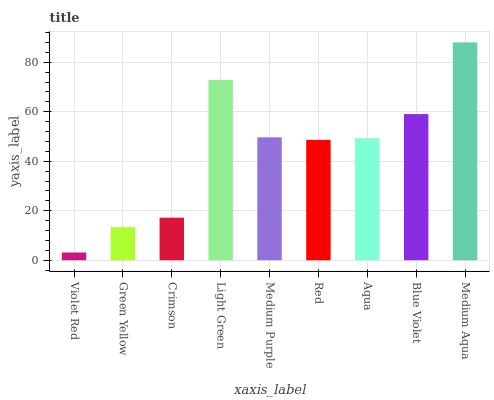Is Violet Red the minimum?
Answer yes or no. Yes. Is Medium Aqua the maximum?
Answer yes or no. Yes. Is Green Yellow the minimum?
Answer yes or no. No. Is Green Yellow the maximum?
Answer yes or no. No. Is Green Yellow greater than Violet Red?
Answer yes or no. Yes. Is Violet Red less than Green Yellow?
Answer yes or no. Yes. Is Violet Red greater than Green Yellow?
Answer yes or no. No. Is Green Yellow less than Violet Red?
Answer yes or no. No. Is Aqua the high median?
Answer yes or no. Yes. Is Aqua the low median?
Answer yes or no. Yes. Is Violet Red the high median?
Answer yes or no. No. Is Crimson the low median?
Answer yes or no. No. 